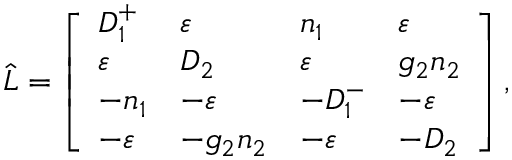<formula> <loc_0><loc_0><loc_500><loc_500>\widehat { L } = \left [ \begin{array} { l l l l } { D _ { 1 } ^ { + } } & { \varepsilon } & { n _ { 1 } } & { \varepsilon } \\ { \varepsilon } & { D _ { 2 } } & { \varepsilon } & { g _ { 2 } n _ { 2 } } \\ { - n _ { 1 } } & { - \varepsilon } & { - D _ { 1 } ^ { - } } & { - \varepsilon } \\ { - \varepsilon } & { - g _ { 2 } n _ { 2 } } & { - \varepsilon } & { - D _ { 2 } } \end{array} \right ] ,</formula> 